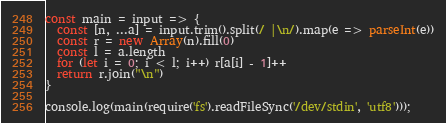<code> <loc_0><loc_0><loc_500><loc_500><_JavaScript_>const main = input => {
  const [n, ...a] = input.trim().split(/ |\n/).map(e => parseInt(e))
  const r = new Array(n).fill(0)
  const l = a.length
  for (let i = 0; i < l; i++) r[a[i] - 1]++
  return r.join("\n")
}

console.log(main(require('fs').readFileSync('/dev/stdin', 'utf8')));</code> 